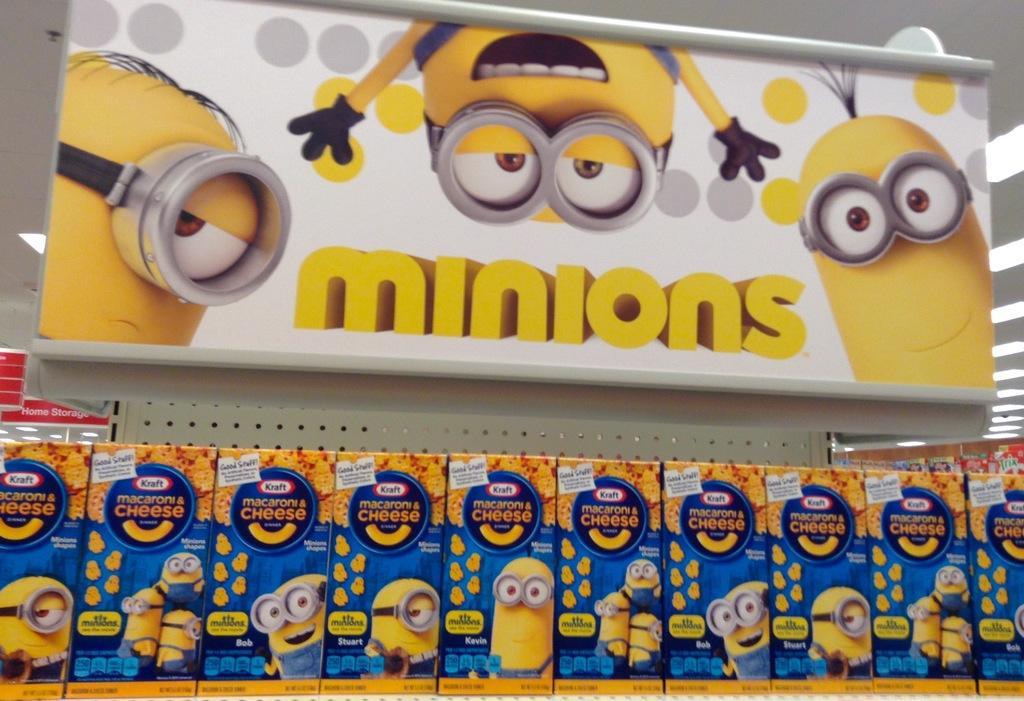Could you give a brief overview of what you see in this image? In this picture we can see boxes, banners and in the background we can see the lights. 